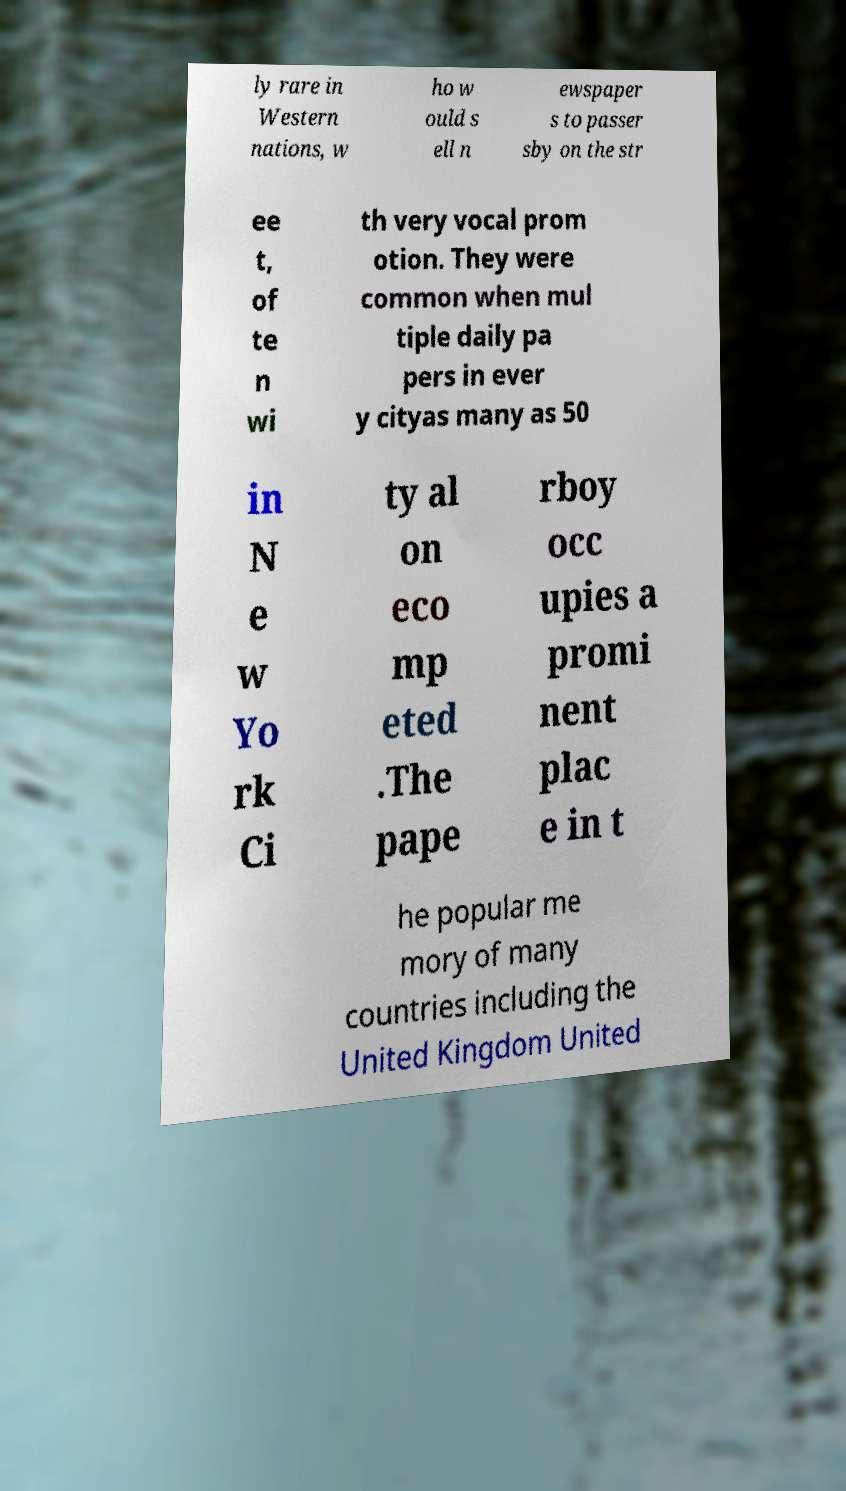Can you read and provide the text displayed in the image?This photo seems to have some interesting text. Can you extract and type it out for me? ly rare in Western nations, w ho w ould s ell n ewspaper s to passer sby on the str ee t, of te n wi th very vocal prom otion. They were common when mul tiple daily pa pers in ever y cityas many as 50 in N e w Yo rk Ci ty al on eco mp eted .The pape rboy occ upies a promi nent plac e in t he popular me mory of many countries including the United Kingdom United 